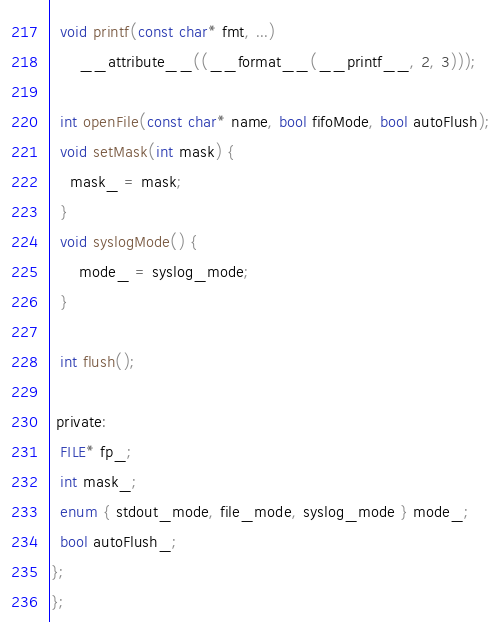Convert code to text. <code><loc_0><loc_0><loc_500><loc_500><_C_>  void printf(const char* fmt, ...)
      __attribute__((__format__(__printf__, 2, 3)));

  int openFile(const char* name, bool fifoMode, bool autoFlush);
  void setMask(int mask) {
    mask_ = mask;
  }
  void syslogMode() {
      mode_ = syslog_mode;
  }

  int flush();

 private:
  FILE* fp_;
  int mask_;
  enum { stdout_mode, file_mode, syslog_mode } mode_;
  bool autoFlush_;
};
};
</code> 